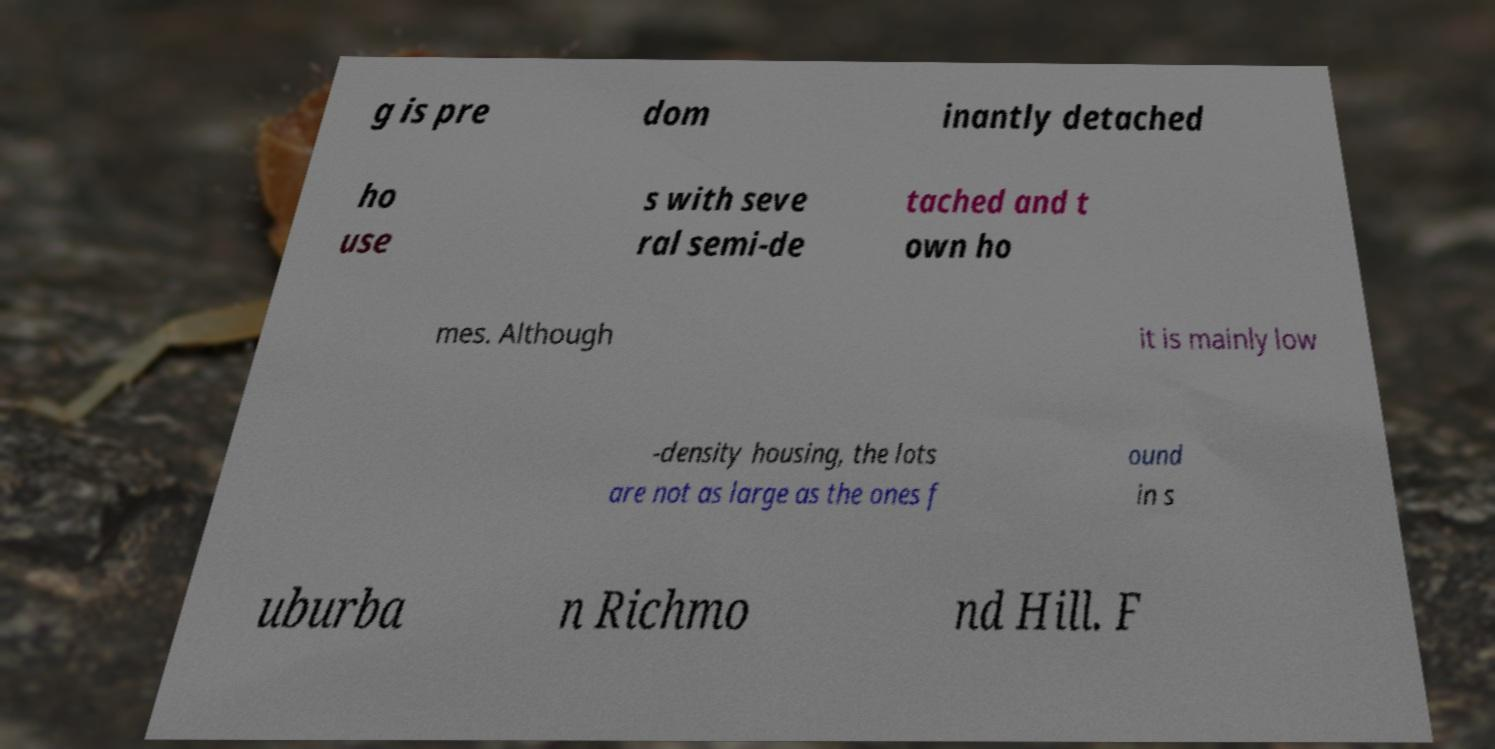There's text embedded in this image that I need extracted. Can you transcribe it verbatim? g is pre dom inantly detached ho use s with seve ral semi-de tached and t own ho mes. Although it is mainly low -density housing, the lots are not as large as the ones f ound in s uburba n Richmo nd Hill. F 